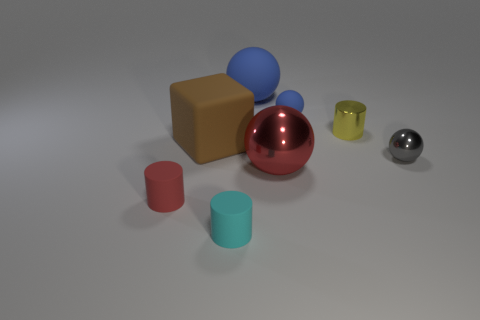Add 1 big red metallic blocks. How many objects exist? 9 Subtract all green balls. Subtract all blue blocks. How many balls are left? 4 Subtract all blocks. How many objects are left? 7 Add 8 large rubber objects. How many large rubber objects exist? 10 Subtract 0 blue cylinders. How many objects are left? 8 Subtract all tiny purple cylinders. Subtract all large brown objects. How many objects are left? 7 Add 1 blue spheres. How many blue spheres are left? 3 